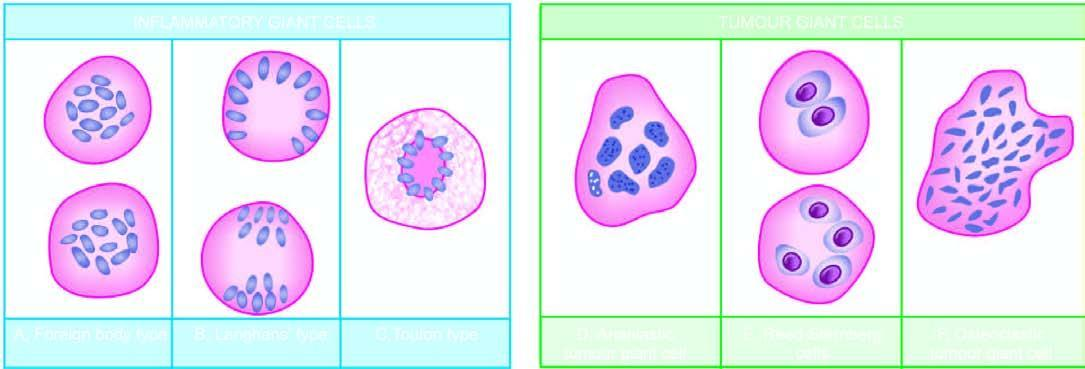what is dispersed throughout the cytoplasm?
Answer the question using a single word or phrase. Foreign body giant cell with uniform nuclei 